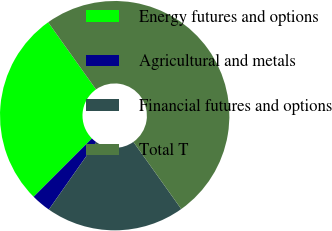<chart> <loc_0><loc_0><loc_500><loc_500><pie_chart><fcel>Energy futures and options<fcel>Agricultural and metals<fcel>Financial futures and options<fcel>Total T<nl><fcel>27.65%<fcel>2.76%<fcel>19.59%<fcel>50.0%<nl></chart> 